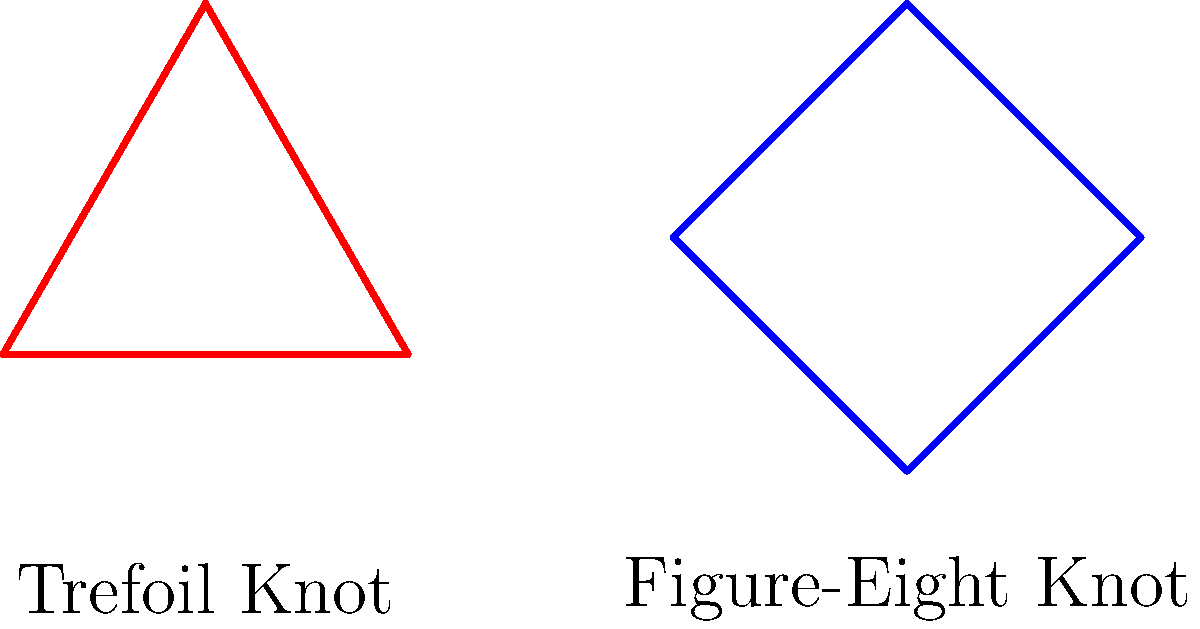In the context of social movements, consider the two knots shown above: the Trefoil Knot and the Figure-Eight Knot. These knots symbolize the interconnectedness of different civil rights campaigns. Which of these two knots has a higher crossing number, and how might this relate to the complexity of organizing multiple intersecting social movements? To answer this question, we need to understand the concept of crossing numbers in knot theory and relate it to social movements:

1. Crossing number: This is the minimum number of crossings that occur in any projection of a knot onto a plane.

2. Trefoil Knot:
   - The Trefoil Knot has a crossing number of 3.
   - It's the simplest non-trivial knot.

3. Figure-Eight Knot:
   - The Figure-Eight Knot has a crossing number of 4.
   - It's more complex than the Trefoil Knot.

4. Relation to social movements:
   - A higher crossing number suggests more complexity and interconnectedness.
   - The Figure-Eight Knot, with its higher crossing number, could represent:
     a) More complex interactions between different aspects of a movement.
     b) A greater number of intersecting issues or campaigns.
     c) The challenge of coordinating multiple, interrelated initiatives.

5. Historical context:
   - In the civil rights movement of the 1960s, various campaigns (voting rights, desegregation, economic justice) intersected.
   - The complexity of managing these intersecting issues mirrors the increased complexity of the Figure-Eight Knot.

Therefore, the Figure-Eight Knot has a higher crossing number (4 vs 3), symbolizing the intricate nature of coordinating multiple, interconnected social justice campaigns within the broader civil rights movement.
Answer: Figure-Eight Knot (crossing number 4); represents greater complexity in coordinating multiple intersecting social movements. 